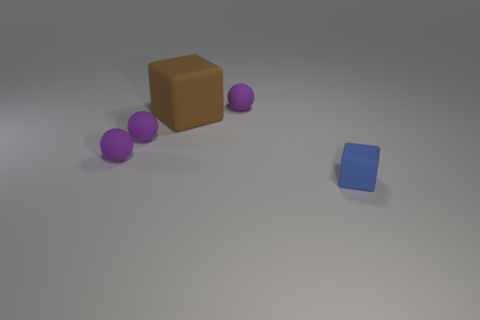Is there any significance to the colors used in the image? While the colors in the image do not necessarily convey a known symbolic meaning, they do contribute to the visual contrast and balance. The purple balls and brown cube create a warm color palette, while the isolated blue cube introduces a cooler tone, possibly suggesting a thematic or spatial separation from the rest. 